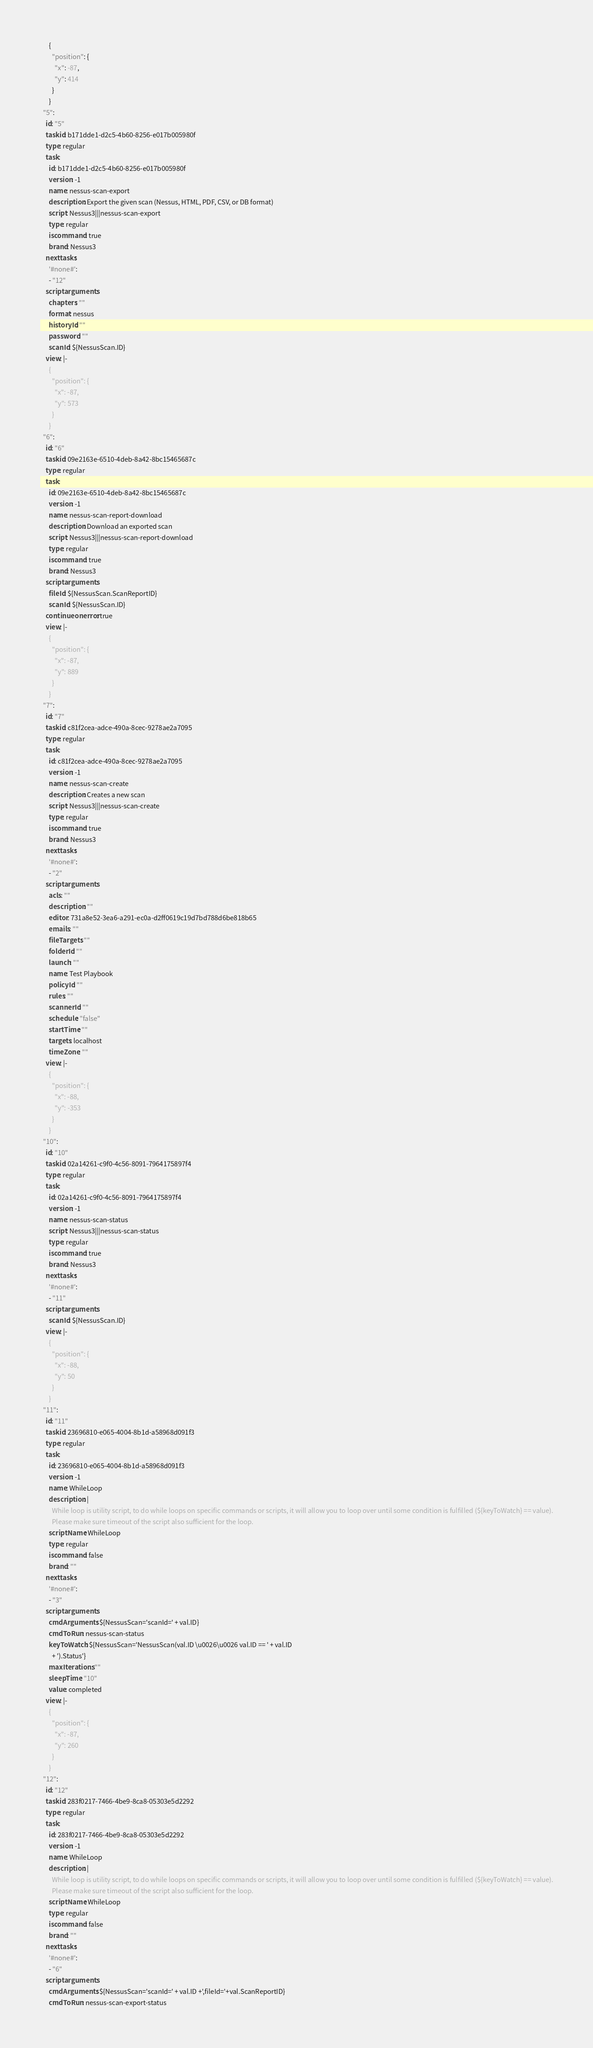Convert code to text. <code><loc_0><loc_0><loc_500><loc_500><_YAML_>      {
        "position": {
          "x": -87,
          "y": 414
        }
      }
  "5":
    id: "5"
    taskid: b171dde1-d2c5-4b60-8256-e017b005980f
    type: regular
    task:
      id: b171dde1-d2c5-4b60-8256-e017b005980f
      version: -1
      name: nessus-scan-export
      description: Export the given scan (Nessus, HTML, PDF, CSV, or DB format)
      script: Nessus3|||nessus-scan-export
      type: regular
      iscommand: true
      brand: Nessus3
    nexttasks:
      '#none#':
      - "12"
    scriptarguments:
      chapters: ""
      format: nessus
      historyId: ""
      password: ""
      scanId: ${NessusScan.ID}
    view: |-
      {
        "position": {
          "x": -87,
          "y": 573
        }
      }
  "6":
    id: "6"
    taskid: 09e2163e-6510-4deb-8a42-8bc15465687c
    type: regular
    task:
      id: 09e2163e-6510-4deb-8a42-8bc15465687c
      version: -1
      name: nessus-scan-report-download
      description: Download an exported scan
      script: Nessus3|||nessus-scan-report-download
      type: regular
      iscommand: true
      brand: Nessus3
    scriptarguments:
      fileId: ${NessusScan.ScanReportID}
      scanId: ${NessusScan.ID}
    continueonerror: true
    view: |-
      {
        "position": {
          "x": -87,
          "y": 889
        }
      }
  "7":
    id: "7"
    taskid: c81f2cea-adce-490a-8cec-9278ae2a7095
    type: regular
    task:
      id: c81f2cea-adce-490a-8cec-9278ae2a7095
      version: -1
      name: nessus-scan-create
      description: Creates a new scan
      script: Nessus3|||nessus-scan-create
      type: regular
      iscommand: true
      brand: Nessus3
    nexttasks:
      '#none#':
      - "2"
    scriptarguments:
      acls: ""
      description: ""
      editor: 731a8e52-3ea6-a291-ec0a-d2ff0619c19d7bd788d6be818b65
      emails: ""
      fileTargets: ""
      folderId: ""
      launch: ""
      name: Test Playbook
      policyId: ""
      rules: ""
      scannerId: ""
      schedule: "false"
      startTime: ""
      targets: localhost
      timeZone: ""
    view: |-
      {
        "position": {
          "x": -88,
          "y": -353
        }
      }
  "10":
    id: "10"
    taskid: 02a14261-c9f0-4c56-8091-7964175897f4
    type: regular
    task:
      id: 02a14261-c9f0-4c56-8091-7964175897f4
      version: -1
      name: nessus-scan-status
      script: Nessus3|||nessus-scan-status
      type: regular
      iscommand: true
      brand: Nessus3
    nexttasks:
      '#none#':
      - "11"
    scriptarguments:
      scanId: ${NessusScan.ID}
    view: |-
      {
        "position": {
          "x": -88,
          "y": 50
        }
      }
  "11":
    id: "11"
    taskid: 23696810-e065-4004-8b1d-a58968d091f3
    type: regular
    task:
      id: 23696810-e065-4004-8b1d-a58968d091f3
      version: -1
      name: WhileLoop
      description: |
        While loop is utility script, to do while loops on specific commands or scripts, it will allow you to loop over until some condition is fulfilled (${keyToWatch} == value).
        Please make sure timeout of the script also sufficient for the loop.
      scriptName: WhileLoop
      type: regular
      iscommand: false
      brand: ""
    nexttasks:
      '#none#':
      - "3"
    scriptarguments:
      cmdArguments: ${NessusScan='scanId=' + val.ID}
      cmdToRun: nessus-scan-status
      keyToWatch: ${NessusScan='NessusScan(val.ID \u0026\u0026 val.ID == ' + val.ID
        + ').Status'}
      maxIterations: ""
      sleepTime: "10"
      value: completed
    view: |-
      {
        "position": {
          "x": -87,
          "y": 260
        }
      }
  "12":
    id: "12"
    taskid: 283f0217-7466-4be9-8ca8-05303e5d2292
    type: regular
    task:
      id: 283f0217-7466-4be9-8ca8-05303e5d2292
      version: -1
      name: WhileLoop
      description: |
        While loop is utility script, to do while loops on specific commands or scripts, it will allow you to loop over until some condition is fulfilled (${keyToWatch} == value).
        Please make sure timeout of the script also sufficient for the loop.
      scriptName: WhileLoop
      type: regular
      iscommand: false
      brand: ""
    nexttasks:
      '#none#':
      - "6"
    scriptarguments:
      cmdArguments: ${NessusScan='scanId=' + val.ID +',fileId='+val.ScanReportID}
      cmdToRun: nessus-scan-export-status</code> 